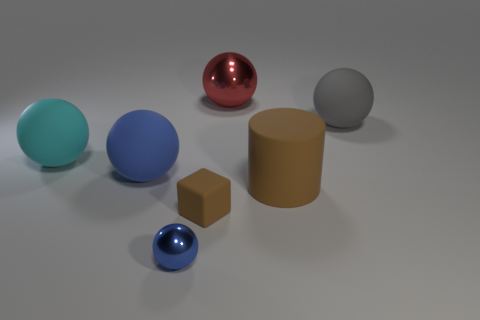Subtract all large balls. How many balls are left? 1 Subtract all gray balls. How many balls are left? 4 Subtract 3 balls. How many balls are left? 2 Add 2 big yellow metallic things. How many objects exist? 9 Subtract all cylinders. How many objects are left? 6 Subtract all purple cubes. Subtract all purple balls. How many cubes are left? 1 Subtract all red blocks. How many blue balls are left? 2 Subtract all large rubber cylinders. Subtract all spheres. How many objects are left? 1 Add 4 blue spheres. How many blue spheres are left? 6 Add 2 big blue matte spheres. How many big blue matte spheres exist? 3 